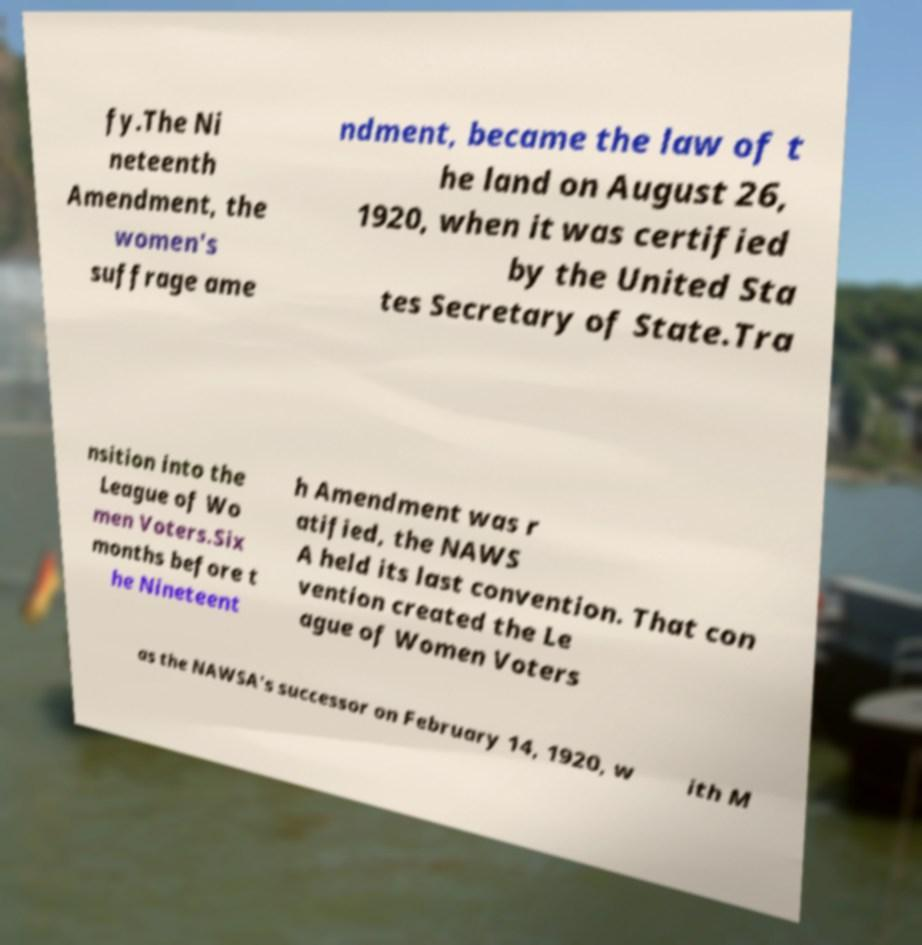I need the written content from this picture converted into text. Can you do that? fy.The Ni neteenth Amendment, the women's suffrage ame ndment, became the law of t he land on August 26, 1920, when it was certified by the United Sta tes Secretary of State.Tra nsition into the League of Wo men Voters.Six months before t he Nineteent h Amendment was r atified, the NAWS A held its last convention. That con vention created the Le ague of Women Voters as the NAWSA's successor on February 14, 1920, w ith M 